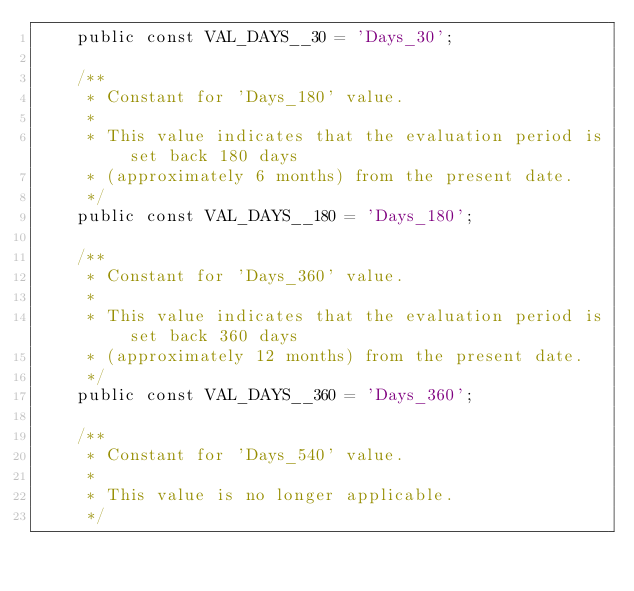Convert code to text. <code><loc_0><loc_0><loc_500><loc_500><_PHP_>    public const VAL_DAYS__30 = 'Days_30';

    /**
     * Constant for 'Days_180' value.
     *
     * This value indicates that the evaluation period is set back 180 days
     * (approximately 6 months) from the present date.
     */
    public const VAL_DAYS__180 = 'Days_180';

    /**
     * Constant for 'Days_360' value.
     *
     * This value indicates that the evaluation period is set back 360 days
     * (approximately 12 months) from the present date.
     */
    public const VAL_DAYS__360 = 'Days_360';

    /**
     * Constant for 'Days_540' value.
     *
     * This value is no longer applicable.
     */</code> 